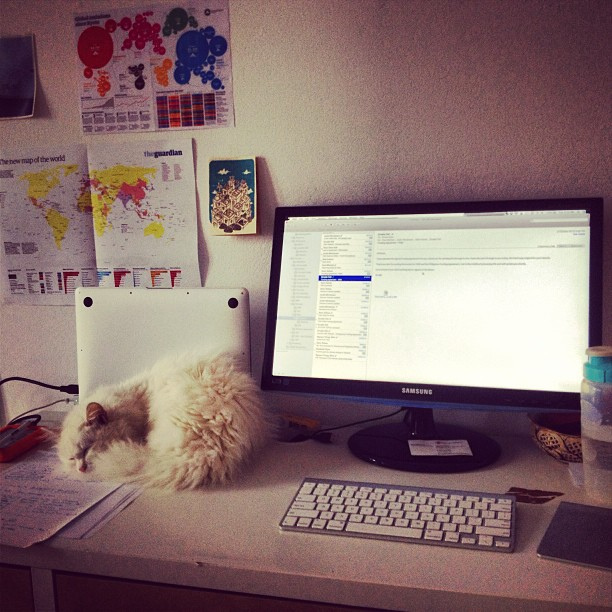Extract all visible text content from this image. SAMSUNG 